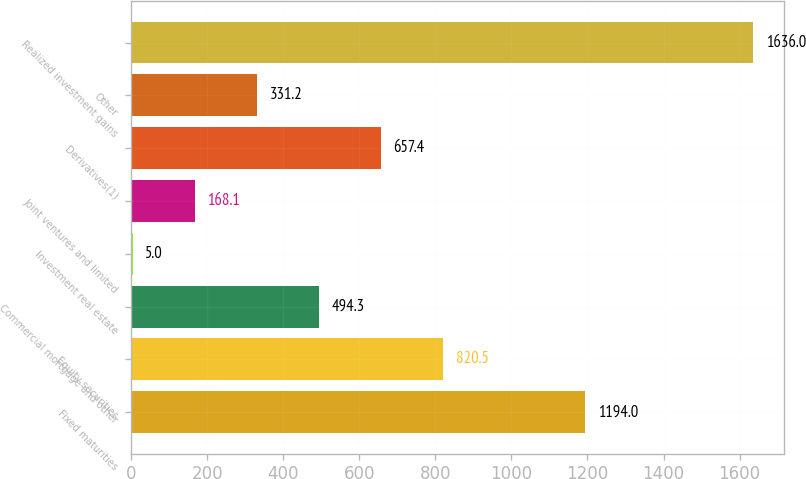Convert chart. <chart><loc_0><loc_0><loc_500><loc_500><bar_chart><fcel>Fixed maturities<fcel>Equity securities<fcel>Commercial mortgage and other<fcel>Investment real estate<fcel>Joint ventures and limited<fcel>Derivatives(1)<fcel>Other<fcel>Realized investment gains<nl><fcel>1194<fcel>820.5<fcel>494.3<fcel>5<fcel>168.1<fcel>657.4<fcel>331.2<fcel>1636<nl></chart> 